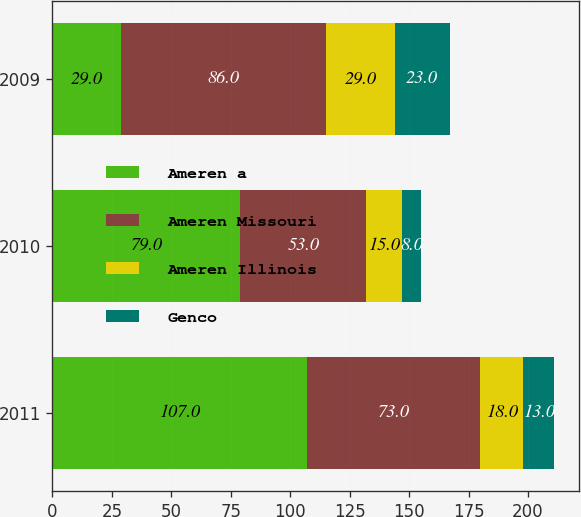Convert chart to OTSL. <chart><loc_0><loc_0><loc_500><loc_500><stacked_bar_chart><ecel><fcel>2011<fcel>2010<fcel>2009<nl><fcel>Ameren a<fcel>107<fcel>79<fcel>29<nl><fcel>Ameren Missouri<fcel>73<fcel>53<fcel>86<nl><fcel>Ameren Illinois<fcel>18<fcel>15<fcel>29<nl><fcel>Genco<fcel>13<fcel>8<fcel>23<nl></chart> 